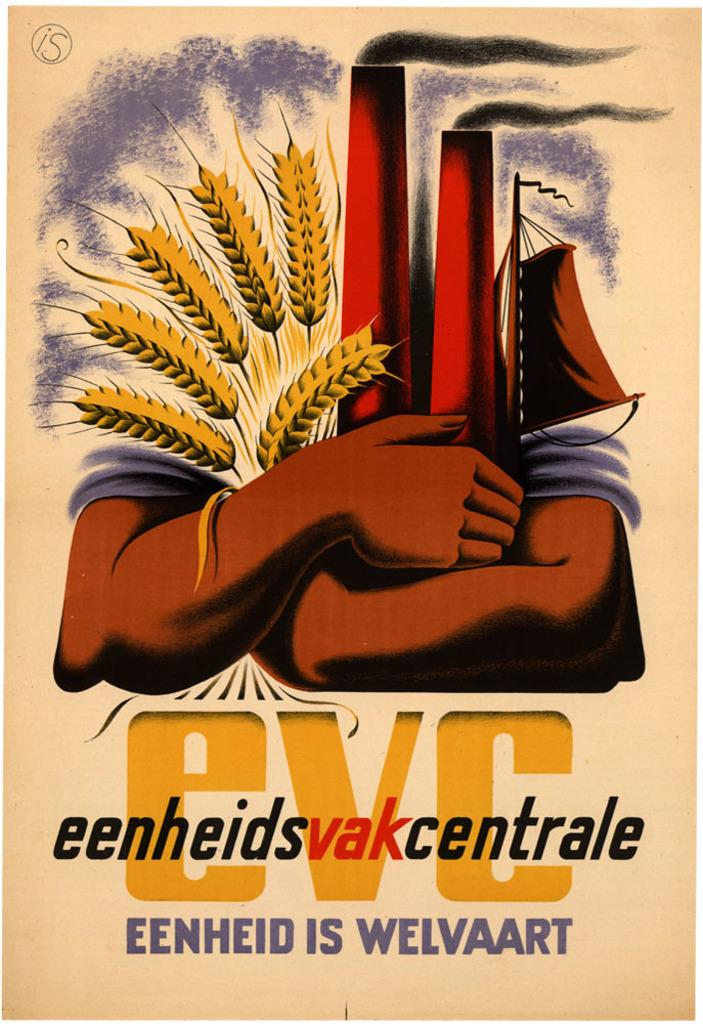What type of book might the image be the cover for? The image is the cover page of a book, but we cannot determine the specific type of book from the provided facts. What is the main subject depicted on the cover? There are wheat grains depicted on the cover. Are there any other objects or elements on the cover besides the wheat grains? Yes, there are other objects held in the arms of a person on the cover. What type of muscle is being flexed by the person holding the tray on the cover? There is no person holding a tray on the cover, and therefore no muscle is being flexed. 